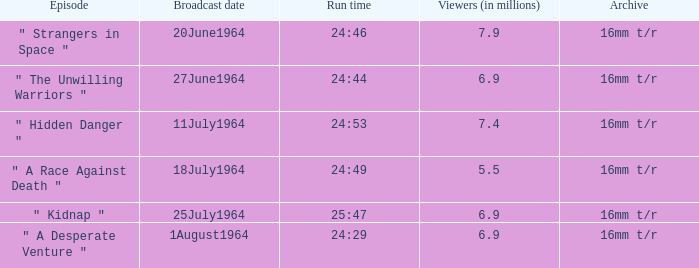How many viewers were there on 1august1964? 6.9. 